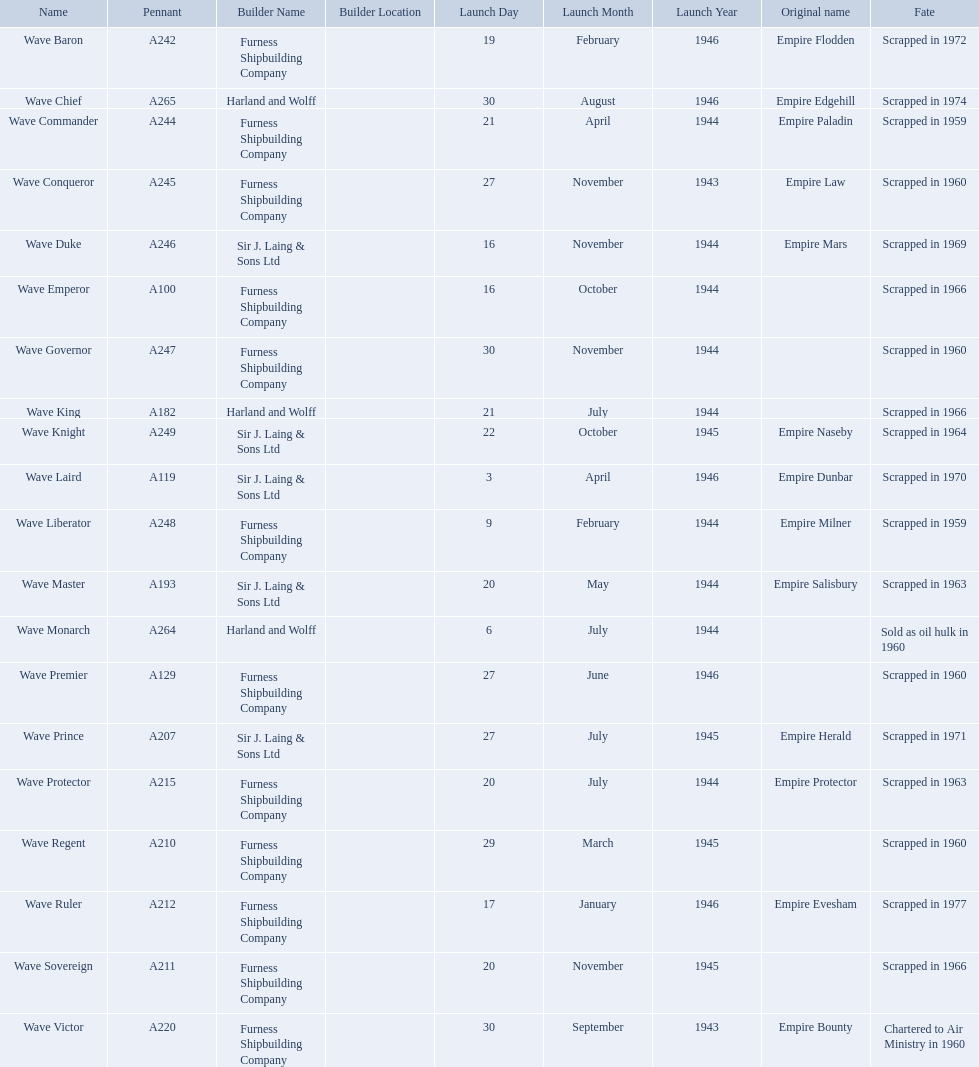What builders launched ships in november of any year? Furness Shipbuilding Company, Sir J. Laing & Sons Ltd, Furness Shipbuilding Company, Furness Shipbuilding Company. What ship builders ships had their original name's changed prior to scrapping? Furness Shipbuilding Company, Sir J. Laing & Sons Ltd. What was the name of the ship that was built in november and had its name changed prior to scrapping only 12 years after its launch? Wave Conqueror. 